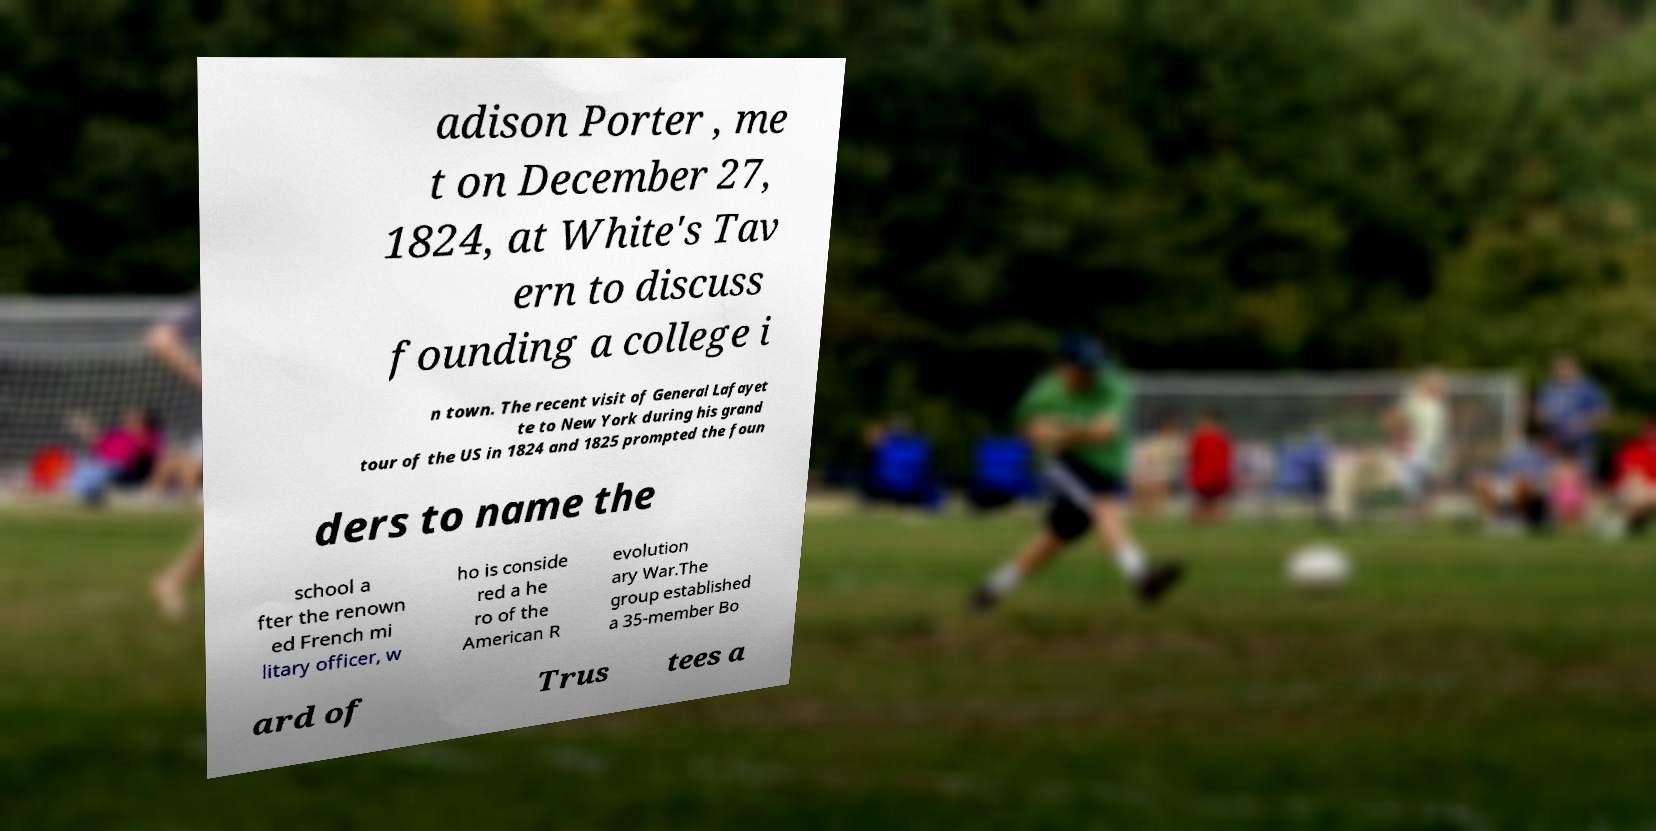Could you extract and type out the text from this image? adison Porter , me t on December 27, 1824, at White's Tav ern to discuss founding a college i n town. The recent visit of General Lafayet te to New York during his grand tour of the US in 1824 and 1825 prompted the foun ders to name the school a fter the renown ed French mi litary officer, w ho is conside red a he ro of the American R evolution ary War.The group established a 35-member Bo ard of Trus tees a 